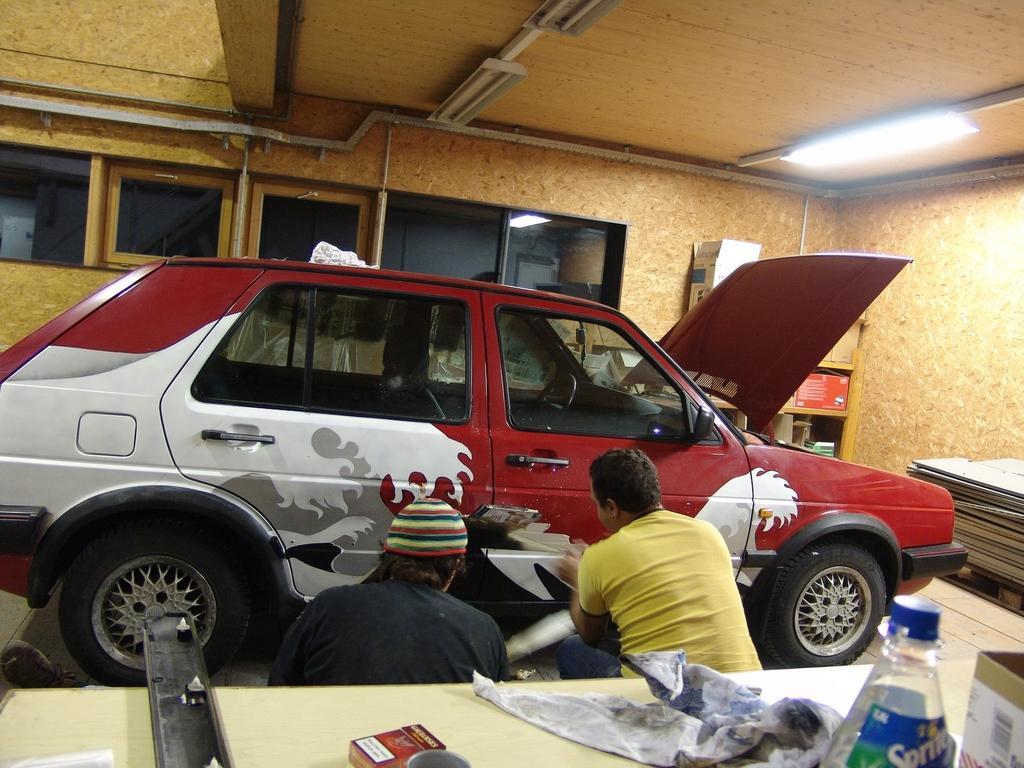Please provide a concise description of this image. In the image in the center we can see two persons were sitting. In front of them we can see the car. In the bottom we can see the table,on table we can see the objects. Coming to the background we can see the wall,glass and door. 